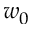<formula> <loc_0><loc_0><loc_500><loc_500>w _ { 0 }</formula> 